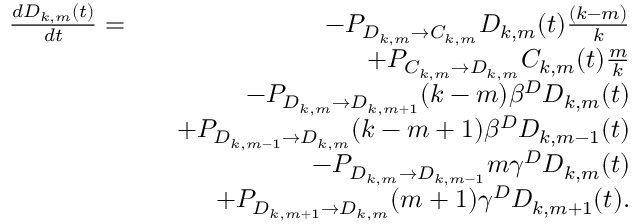Convert formula to latex. <formula><loc_0><loc_0><loc_500><loc_500>\begin{array} { r l r } { \frac { d D _ { k , m } ( t ) } { d t } = } & { - P _ { D _ { k , m } \rightarrow C _ { k , m } } D _ { k , m } ( t ) \frac { ( k - m ) } { k } } \\ & { + P _ { C _ { k , m } \rightarrow D _ { k , m } } C _ { k , m } ( t ) \frac { m } { k } } \\ & { - P _ { D _ { k , m } \rightarrow D _ { k , m + 1 } } ( k - m ) \beta ^ { D } D _ { k , m } ( t ) } \\ & { + P _ { D _ { k , m - 1 } \rightarrow D _ { k , m } } ( k - m + 1 ) \beta ^ { D } D _ { k , m - 1 } ( t ) } \\ & { - P _ { D _ { k , m } \rightarrow D _ { k , m - 1 } } m \gamma ^ { D } D _ { k , m } ( t ) } \\ & { + P _ { D _ { k , m + 1 } \rightarrow D _ { k , m } } ( m + 1 ) \gamma ^ { D } D _ { k , m + 1 } ( t ) . } \end{array}</formula> 